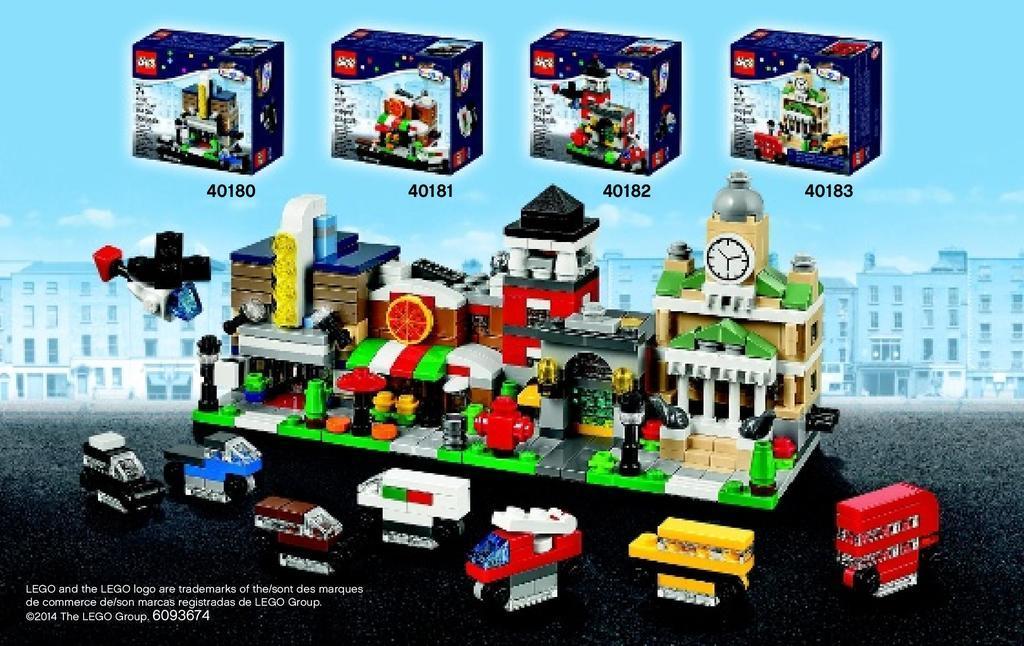Describe this image in one or two sentences. In this image, I can see a poster with the number and pictures of a LEGO puzzle, toys, boxes, buildings and the sky. In the bottom left corner of the image, there is a watermark. 